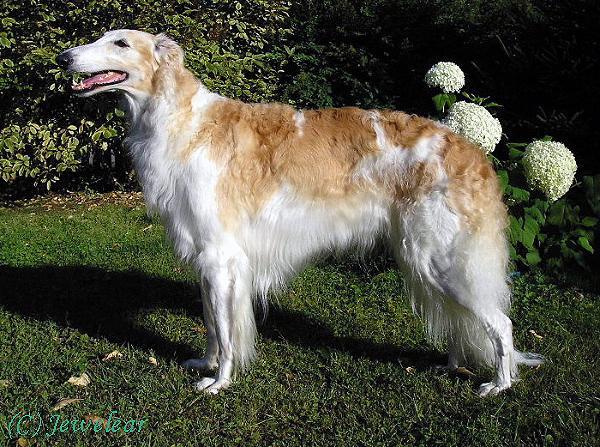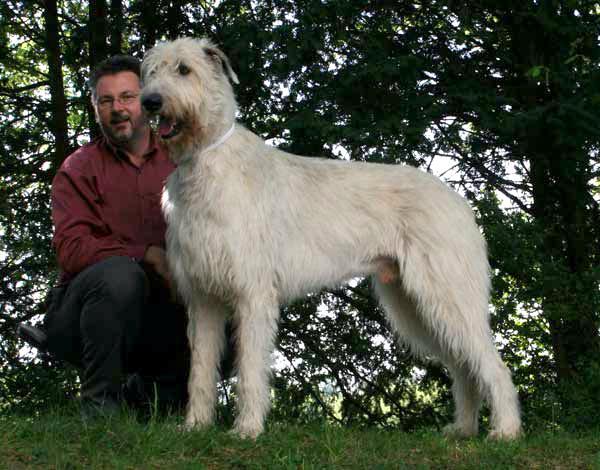The first image is the image on the left, the second image is the image on the right. For the images shown, is this caption "Each image shows one hound standing outdoors." true? Answer yes or no. Yes. The first image is the image on the left, the second image is the image on the right. Evaluate the accuracy of this statement regarding the images: "There are 2 dogs standing on grass.". Is it true? Answer yes or no. Yes. 